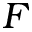Convert formula to latex. <formula><loc_0><loc_0><loc_500><loc_500>F</formula> 